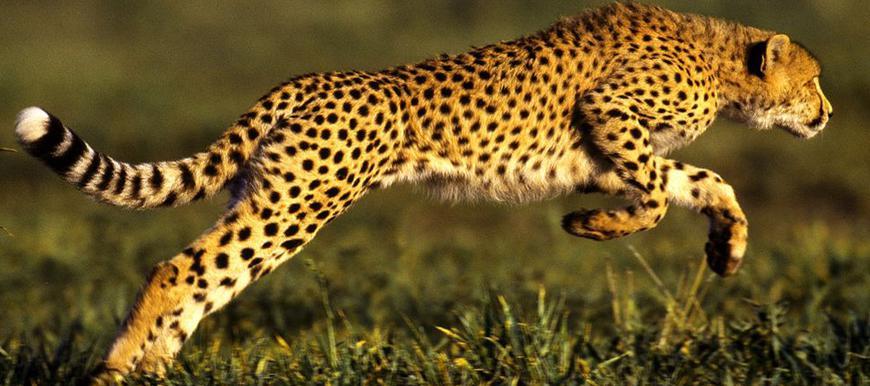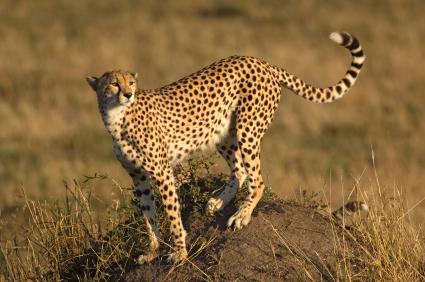The first image is the image on the left, the second image is the image on the right. Examine the images to the left and right. Is the description "Not more than one cheetah in any of the pictures" accurate? Answer yes or no. Yes. The first image is the image on the left, the second image is the image on the right. For the images shown, is this caption "There is a single cheetah running in the left image." true? Answer yes or no. Yes. 